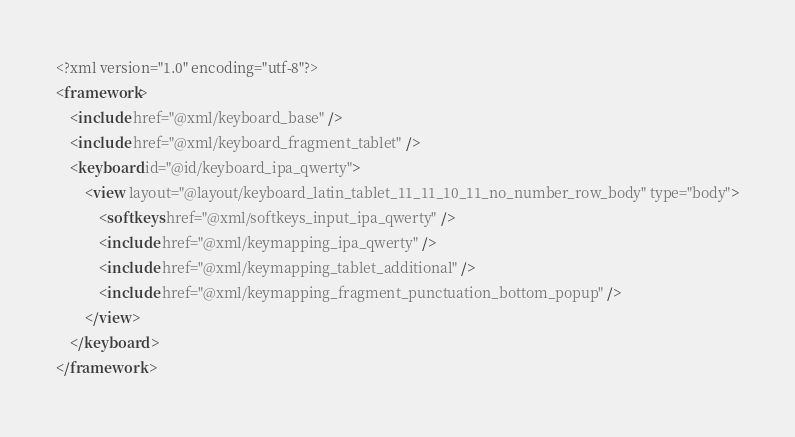<code> <loc_0><loc_0><loc_500><loc_500><_XML_><?xml version="1.0" encoding="utf-8"?>
<framework>
    <include href="@xml/keyboard_base" />
    <include href="@xml/keyboard_fragment_tablet" />
    <keyboard id="@id/keyboard_ipa_qwerty">
        <view layout="@layout/keyboard_latin_tablet_11_11_10_11_no_number_row_body" type="body">
            <softkeys href="@xml/softkeys_input_ipa_qwerty" />
            <include href="@xml/keymapping_ipa_qwerty" />
            <include href="@xml/keymapping_tablet_additional" />
            <include href="@xml/keymapping_fragment_punctuation_bottom_popup" />
        </view>
    </keyboard>
</framework></code> 